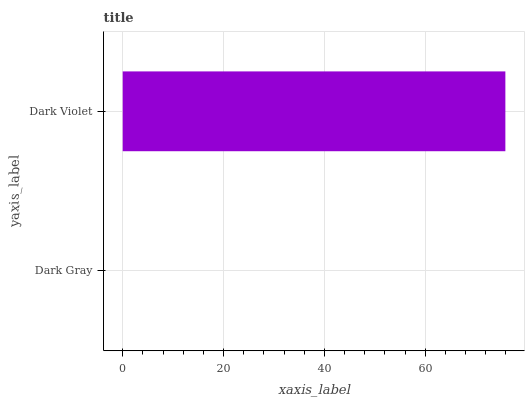Is Dark Gray the minimum?
Answer yes or no. Yes. Is Dark Violet the maximum?
Answer yes or no. Yes. Is Dark Violet the minimum?
Answer yes or no. No. Is Dark Violet greater than Dark Gray?
Answer yes or no. Yes. Is Dark Gray less than Dark Violet?
Answer yes or no. Yes. Is Dark Gray greater than Dark Violet?
Answer yes or no. No. Is Dark Violet less than Dark Gray?
Answer yes or no. No. Is Dark Violet the high median?
Answer yes or no. Yes. Is Dark Gray the low median?
Answer yes or no. Yes. Is Dark Gray the high median?
Answer yes or no. No. Is Dark Violet the low median?
Answer yes or no. No. 